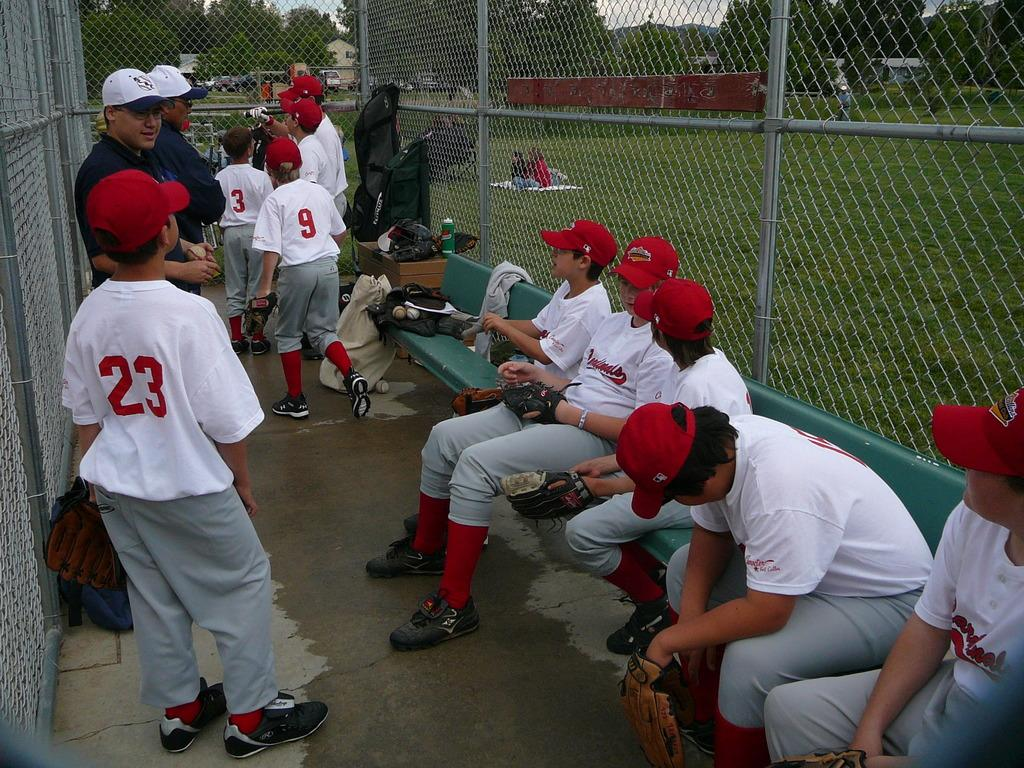How many people are in the image? There are people in the image, but the exact number is not specified. What are some of the people doing in the image? Some people are standing, and some are sitting. What can be seen in the background of the image? There are trees and buildings in the image. What is the purpose of the net in the image? The purpose of the net is not specified, but it is present in the image. What other objects can be seen in the image? There are other objects in the image, but their specific nature is not mentioned. How many cows are grazing in the image? There are no cows present in the image. What type of nut is being used to build the development in the image? There is no development or nut mentioned in the image. 